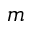Convert formula to latex. <formula><loc_0><loc_0><loc_500><loc_500>m</formula> 